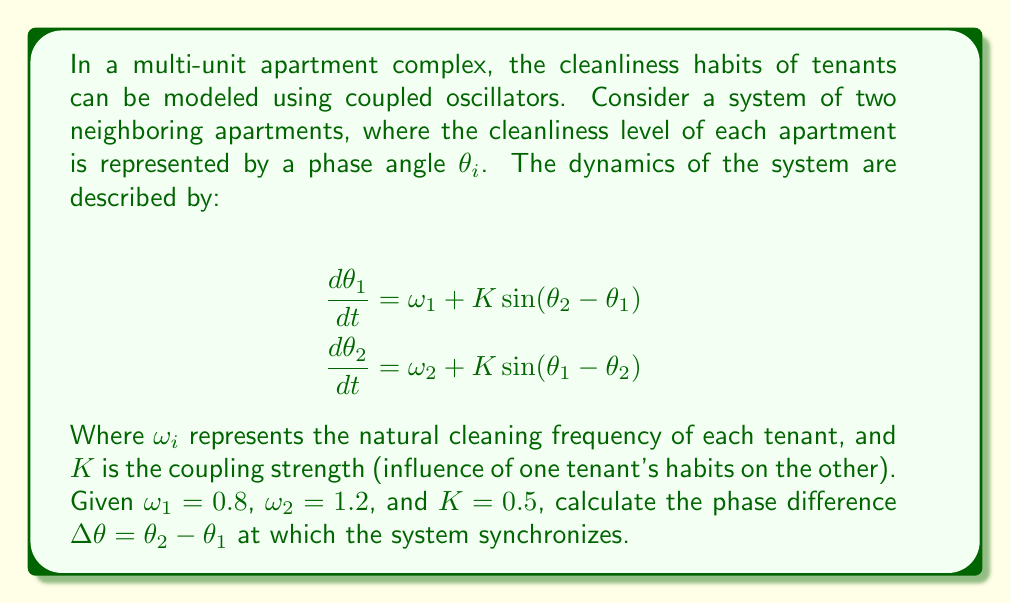Teach me how to tackle this problem. To solve this problem, we'll follow these steps:

1) In a synchronized state, the phase difference $\Delta\theta = \theta_2 - \theta_1$ remains constant. This means:

   $$\frac{d}{dt}(\theta_2 - \theta_1) = \frac{d\theta_2}{dt} - \frac{d\theta_1}{dt} = 0$$

2) Substituting the given equations:

   $$(\omega_2 + K\sin(\theta_1 - \theta_2)) - (\omega_1 + K\sin(\theta_2 - \theta_1)) = 0$$

3) Simplify, noting that $\sin(\theta_1 - \theta_2) = -\sin(\theta_2 - \theta_1)$:

   $$\omega_2 - \omega_1 - 2K\sin(\theta_2 - \theta_1) = 0$$

4) Let $\Delta\theta = \theta_2 - \theta_1$. Then:

   $$\omega_2 - \omega_1 = 2K\sin(\Delta\theta)$$

5) Rearrange:

   $$\sin(\Delta\theta) = \frac{\omega_2 - \omega_1}{2K}$$

6) Substitute the given values:

   $$\sin(\Delta\theta) = \frac{1.2 - 0.8}{2(0.5)} = \frac{0.4}{1} = 0.4$$

7) To find $\Delta\theta$, we take the inverse sine (arcsin):

   $$\Delta\theta = \arcsin(0.4)$$

8) Calculate:

   $$\Delta\theta \approx 0.4115 \text{ radians}$$

This phase difference represents the stable state where the cleaning habits of the two tenants synchronize, despite their different natural frequencies.
Answer: $\Delta\theta \approx 0.4115 \text{ radians}$ 